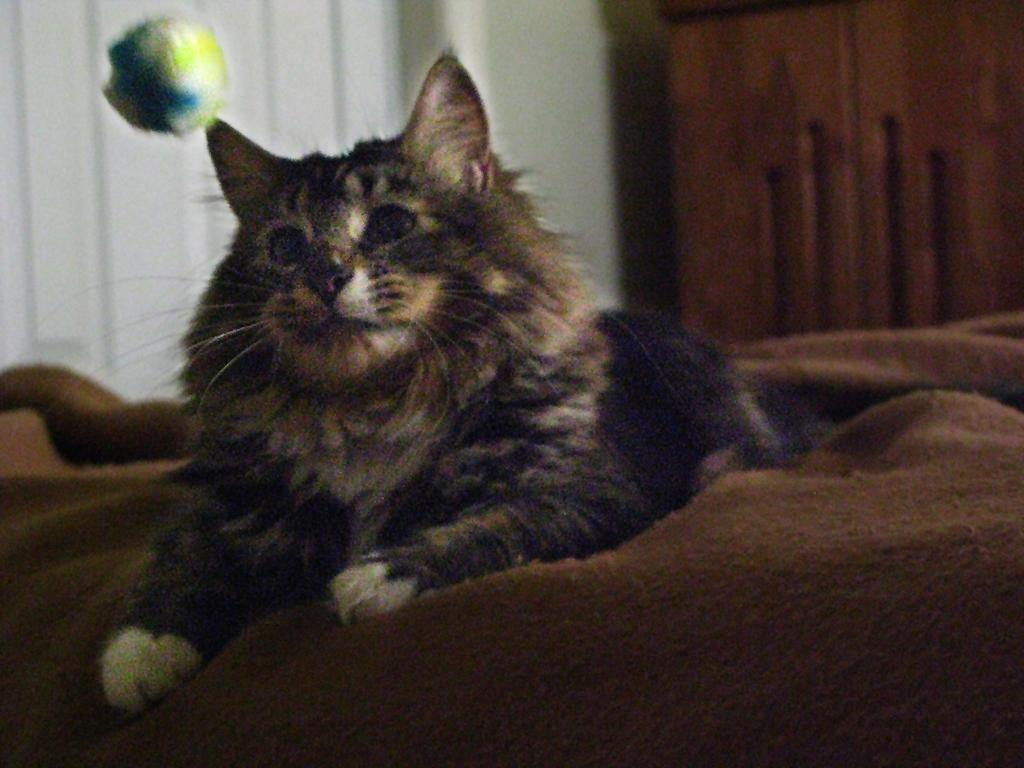What type of animal is in the image? There is a cat in the image. Can you describe the color of the cat? The cat is brown and black in color. Where is the cat sitting in the image? The cat is sitting on a brown bed sheet. What can be seen in the background of the image? There is a wooden wardrobe in the background of the image. What color is the wall behind the cat? The wall behind the cat is white in color. What type of mist can be seen surrounding the cat in the image? There is no mist present in the image; it is a clear image of a cat sitting on a brown bed sheet. 